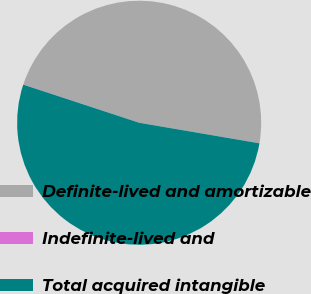Convert chart. <chart><loc_0><loc_0><loc_500><loc_500><pie_chart><fcel>Definite-lived and amortizable<fcel>Indefinite-lived and<fcel>Total acquired intangible<nl><fcel>47.61%<fcel>0.03%<fcel>52.36%<nl></chart> 